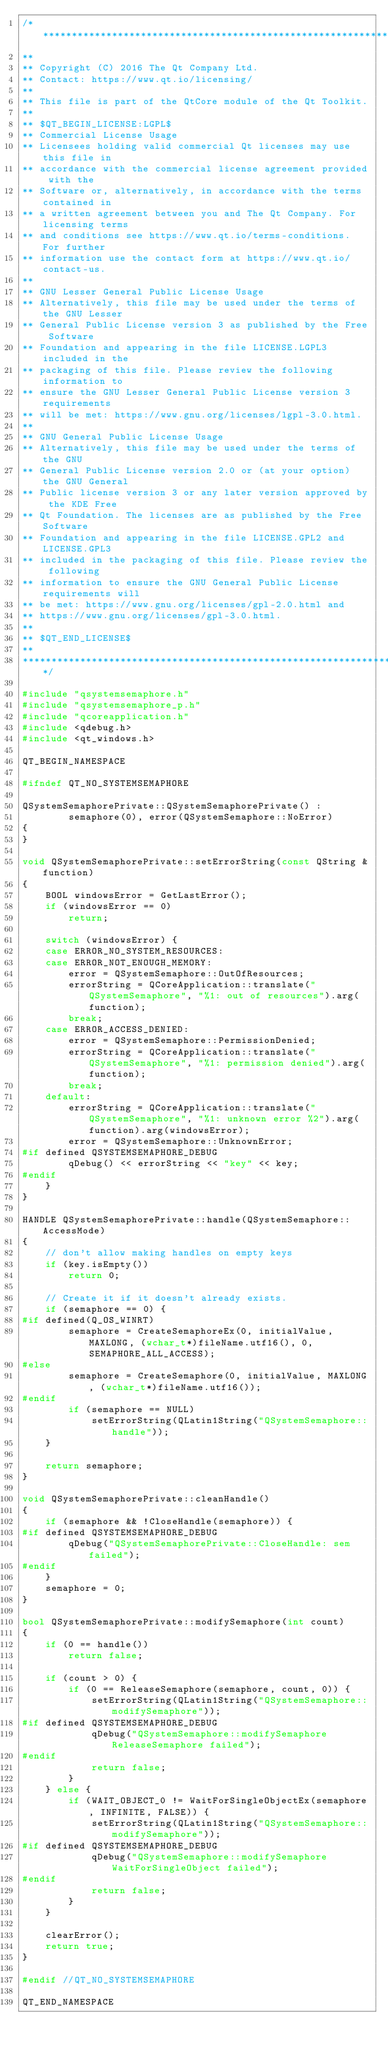Convert code to text. <code><loc_0><loc_0><loc_500><loc_500><_C++_>/****************************************************************************
**
** Copyright (C) 2016 The Qt Company Ltd.
** Contact: https://www.qt.io/licensing/
**
** This file is part of the QtCore module of the Qt Toolkit.
**
** $QT_BEGIN_LICENSE:LGPL$
** Commercial License Usage
** Licensees holding valid commercial Qt licenses may use this file in
** accordance with the commercial license agreement provided with the
** Software or, alternatively, in accordance with the terms contained in
** a written agreement between you and The Qt Company. For licensing terms
** and conditions see https://www.qt.io/terms-conditions. For further
** information use the contact form at https://www.qt.io/contact-us.
**
** GNU Lesser General Public License Usage
** Alternatively, this file may be used under the terms of the GNU Lesser
** General Public License version 3 as published by the Free Software
** Foundation and appearing in the file LICENSE.LGPL3 included in the
** packaging of this file. Please review the following information to
** ensure the GNU Lesser General Public License version 3 requirements
** will be met: https://www.gnu.org/licenses/lgpl-3.0.html.
**
** GNU General Public License Usage
** Alternatively, this file may be used under the terms of the GNU
** General Public License version 2.0 or (at your option) the GNU General
** Public license version 3 or any later version approved by the KDE Free
** Qt Foundation. The licenses are as published by the Free Software
** Foundation and appearing in the file LICENSE.GPL2 and LICENSE.GPL3
** included in the packaging of this file. Please review the following
** information to ensure the GNU General Public License requirements will
** be met: https://www.gnu.org/licenses/gpl-2.0.html and
** https://www.gnu.org/licenses/gpl-3.0.html.
**
** $QT_END_LICENSE$
**
****************************************************************************/

#include "qsystemsemaphore.h"
#include "qsystemsemaphore_p.h"
#include "qcoreapplication.h"
#include <qdebug.h>
#include <qt_windows.h>

QT_BEGIN_NAMESPACE

#ifndef QT_NO_SYSTEMSEMAPHORE

QSystemSemaphorePrivate::QSystemSemaphorePrivate() :
        semaphore(0), error(QSystemSemaphore::NoError)
{
}

void QSystemSemaphorePrivate::setErrorString(const QString &function)
{
    BOOL windowsError = GetLastError();
    if (windowsError == 0)
        return;

    switch (windowsError) {
    case ERROR_NO_SYSTEM_RESOURCES:
    case ERROR_NOT_ENOUGH_MEMORY:
        error = QSystemSemaphore::OutOfResources;
        errorString = QCoreApplication::translate("QSystemSemaphore", "%1: out of resources").arg(function);
        break;
    case ERROR_ACCESS_DENIED:
        error = QSystemSemaphore::PermissionDenied;
        errorString = QCoreApplication::translate("QSystemSemaphore", "%1: permission denied").arg(function);
        break;
    default:
        errorString = QCoreApplication::translate("QSystemSemaphore", "%1: unknown error %2").arg(function).arg(windowsError);
        error = QSystemSemaphore::UnknownError;
#if defined QSYSTEMSEMAPHORE_DEBUG
        qDebug() << errorString << "key" << key;
#endif
    }
}

HANDLE QSystemSemaphorePrivate::handle(QSystemSemaphore::AccessMode)
{
    // don't allow making handles on empty keys
    if (key.isEmpty())
        return 0;

    // Create it if it doesn't already exists.
    if (semaphore == 0) {
#if defined(Q_OS_WINRT)
        semaphore = CreateSemaphoreEx(0, initialValue, MAXLONG, (wchar_t*)fileName.utf16(), 0, SEMAPHORE_ALL_ACCESS);
#else
        semaphore = CreateSemaphore(0, initialValue, MAXLONG, (wchar_t*)fileName.utf16());
#endif
        if (semaphore == NULL)
            setErrorString(QLatin1String("QSystemSemaphore::handle"));
    }

    return semaphore;
}

void QSystemSemaphorePrivate::cleanHandle()
{
    if (semaphore && !CloseHandle(semaphore)) {
#if defined QSYSTEMSEMAPHORE_DEBUG
        qDebug("QSystemSemaphorePrivate::CloseHandle: sem failed");
#endif
    }
    semaphore = 0;
}

bool QSystemSemaphorePrivate::modifySemaphore(int count)
{
    if (0 == handle())
        return false;

    if (count > 0) {
        if (0 == ReleaseSemaphore(semaphore, count, 0)) {
            setErrorString(QLatin1String("QSystemSemaphore::modifySemaphore"));
#if defined QSYSTEMSEMAPHORE_DEBUG
            qDebug("QSystemSemaphore::modifySemaphore ReleaseSemaphore failed");
#endif
            return false;
        }
    } else {
        if (WAIT_OBJECT_0 != WaitForSingleObjectEx(semaphore, INFINITE, FALSE)) {
            setErrorString(QLatin1String("QSystemSemaphore::modifySemaphore"));
#if defined QSYSTEMSEMAPHORE_DEBUG
            qDebug("QSystemSemaphore::modifySemaphore WaitForSingleObject failed");
#endif
            return false;
        }
    }

    clearError();
    return true;
}

#endif //QT_NO_SYSTEMSEMAPHORE

QT_END_NAMESPACE
</code> 